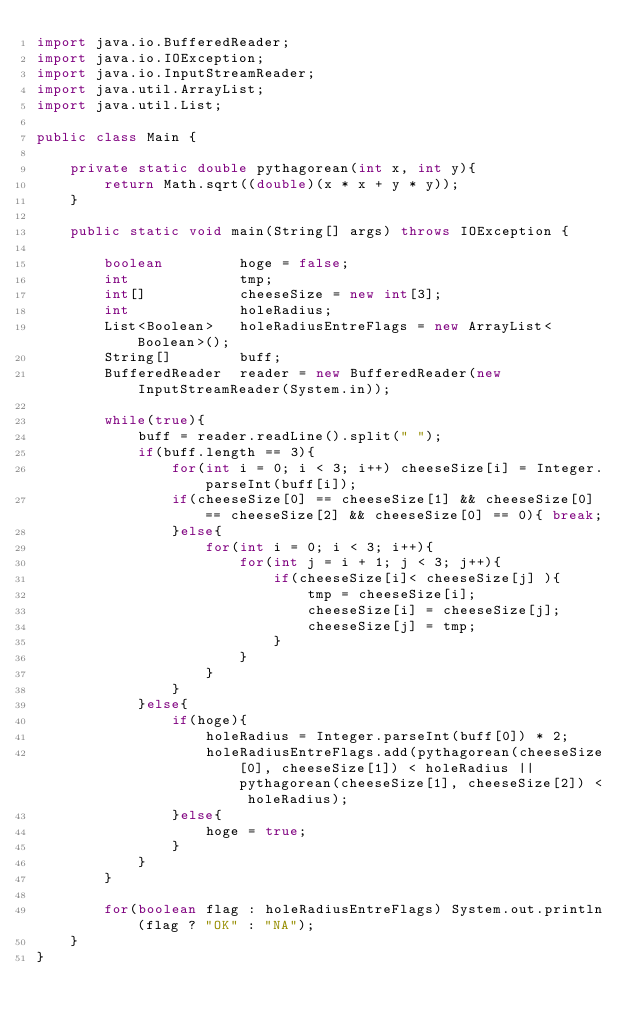Convert code to text. <code><loc_0><loc_0><loc_500><loc_500><_Java_>import java.io.BufferedReader;
import java.io.IOException;
import java.io.InputStreamReader;
import java.util.ArrayList;
import java.util.List;

public class Main {

	private static double pythagorean(int x, int y){
		return Math.sqrt((double)(x * x + y * y));
	}

	public static void main(String[] args) throws IOException {

		boolean			hoge = false;
		int 			tmp;
		int[] 			cheeseSize = new int[3];
		int				holeRadius;
		List<Boolean>	holeRadiusEntreFlags = new ArrayList<Boolean>();
		String[]		buff;
		BufferedReader	reader = new BufferedReader(new InputStreamReader(System.in));

		while(true){
			buff = reader.readLine().split(" ");
			if(buff.length == 3){
				for(int i = 0; i < 3; i++) cheeseSize[i] = Integer.parseInt(buff[i]);
				if(cheeseSize[0] == cheeseSize[1] && cheeseSize[0] == cheeseSize[2] && cheeseSize[0] == 0){ break;
				}else{
					for(int i = 0; i < 3; i++){
						for(int j = i + 1; j < 3; j++){
							if(cheeseSize[i]< cheeseSize[j] ){
								tmp = cheeseSize[i];
								cheeseSize[i] = cheeseSize[j];
								cheeseSize[j] = tmp;
							}
						}
					}
				}
			}else{
				if(hoge){
					holeRadius = Integer.parseInt(buff[0]) * 2;
					holeRadiusEntreFlags.add(pythagorean(cheeseSize[0], cheeseSize[1]) < holeRadius || pythagorean(cheeseSize[1], cheeseSize[2]) < holeRadius);
				}else{
					hoge = true;
				}
			}
		}

		for(boolean flag : holeRadiusEntreFlags) System.out.println(flag ? "OK" : "NA");
	}
}</code> 